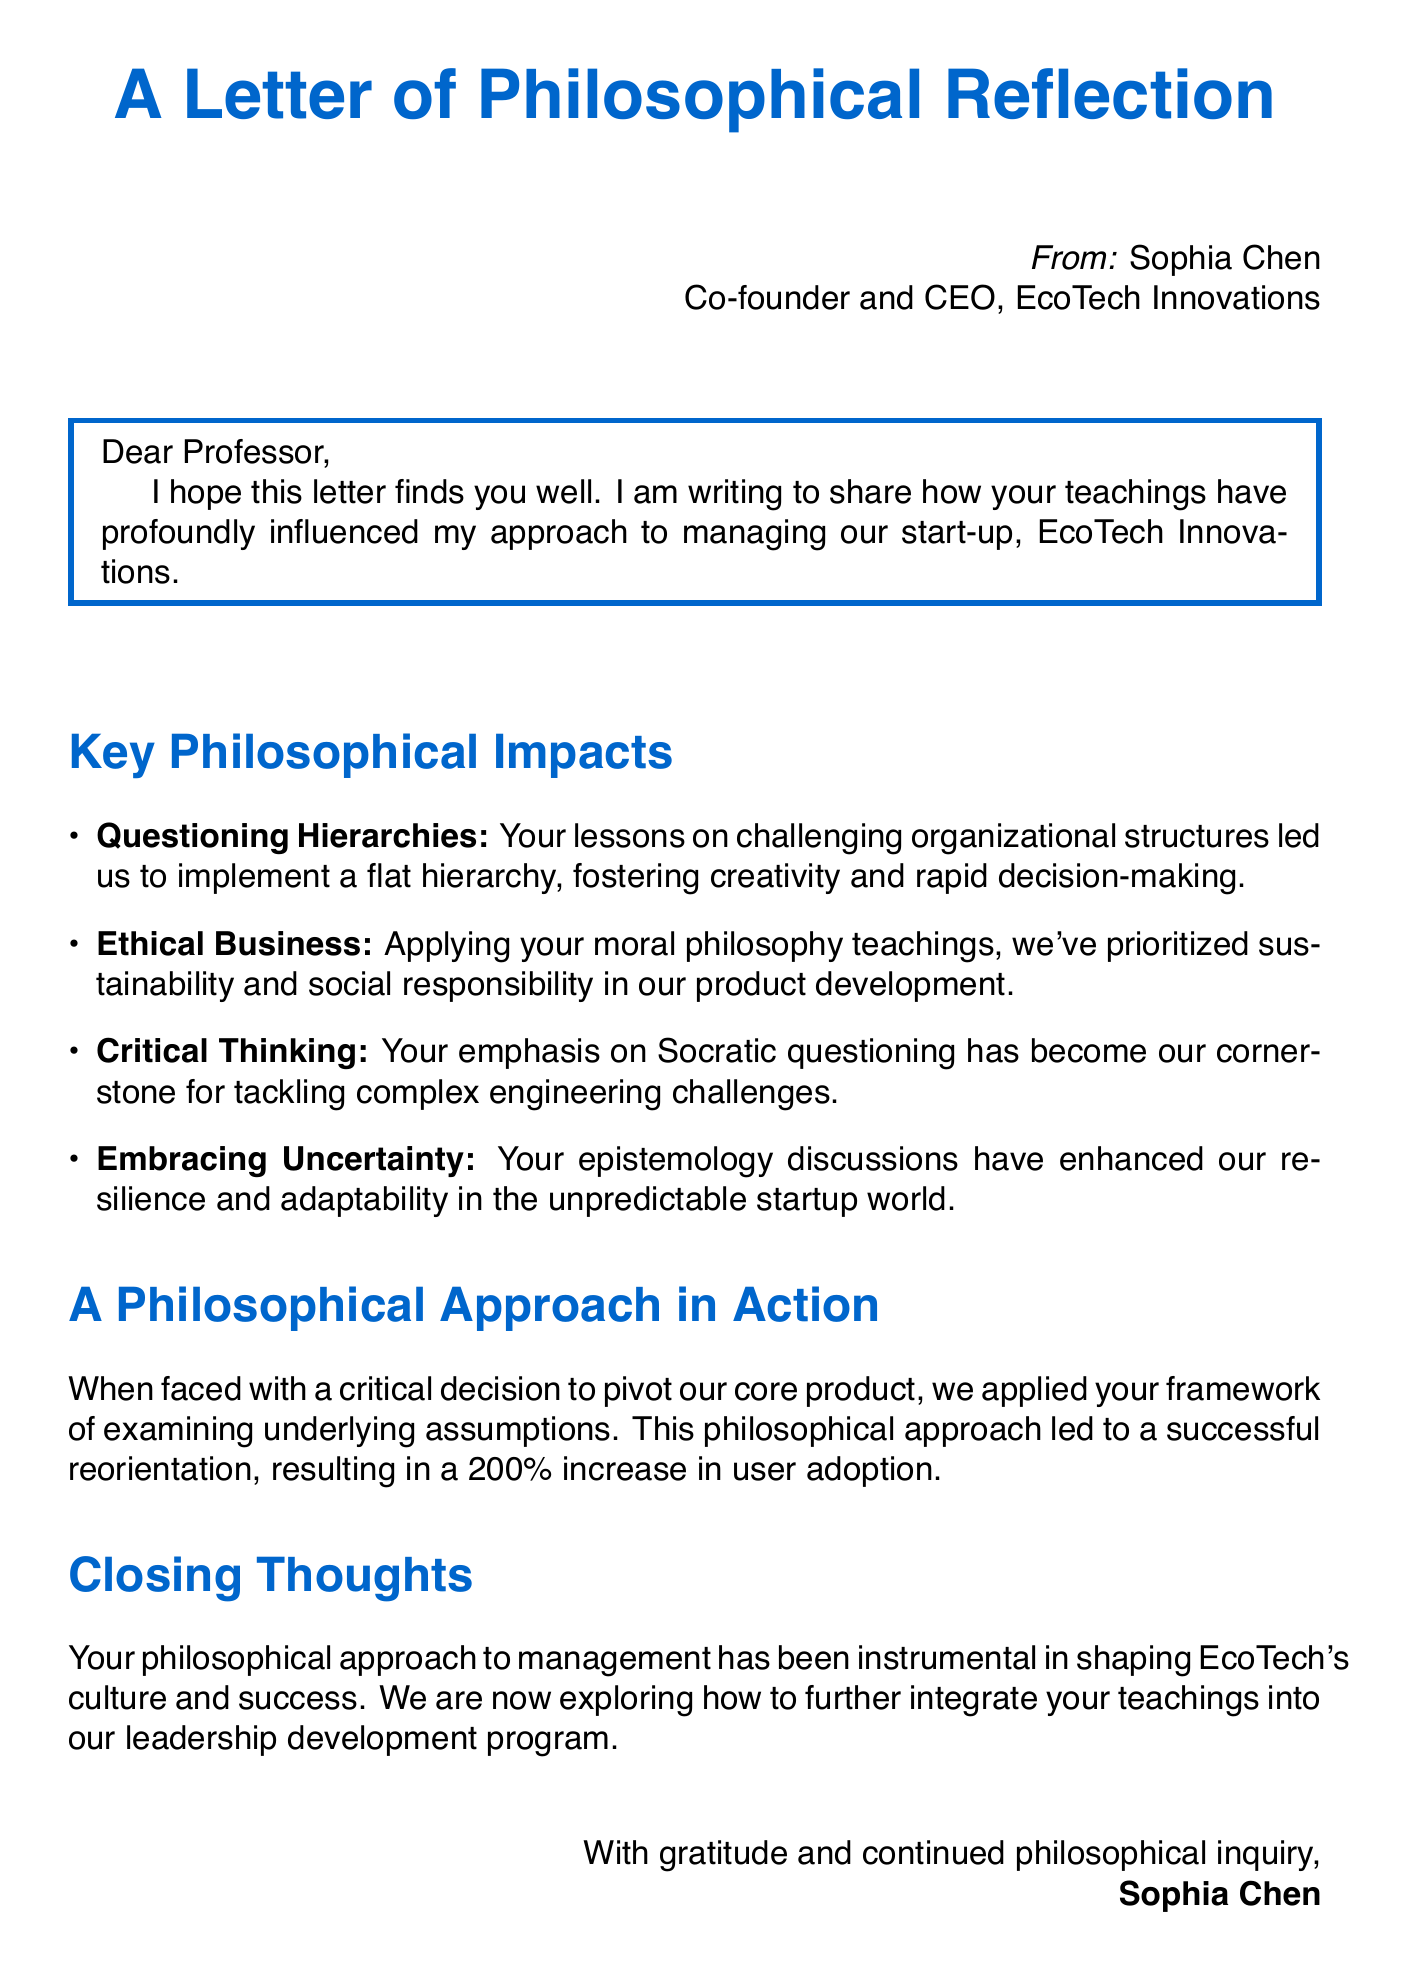What is the name of the sender? The sender's name is mentioned in the document as Sophia Chen.
Answer: Sophia Chen What is the company associated with the sender? The document specifies that the sender is from EcoTech Innovations.
Answer: EcoTech Innovations What position does Sophia Chen hold? Sophia Chen's position is stated in the document as Co-founder and CEO.
Answer: Co-founder and CEO What is the percentage increase in user adoption after the product pivot? The document notes a 200% increase in user adoption after applying a philosophical approach.
Answer: 200% What is one key topic discussed in relation to ethical considerations? The document highlights sustainability as a priority in product development based on ethical teachings.
Answer: Sustainability How did Sophia Chen describe the team’s approach to problem-solving? The document refers to Socratic questioning as the cornerstone of the team's problem-solving methodology.
Answer: Socratic questioning What framework did they use to analyze their market trends? Sophia Chen applied the framework of examining underlying assumptions to analyze market trends and customer needs.
Answer: Examining underlying assumptions What future plans does EcoTech have regarding the teachings? The document mentions plans to integrate more teachings into their leadership development program.
Answer: Leadership development program What impact did the sender attribute to the professor's teachings? The document states that the professor's philosophical approach has been instrumental in shaping EcoTech's culture and success.
Answer: Instrumental in shaping EcoTech's culture and success 